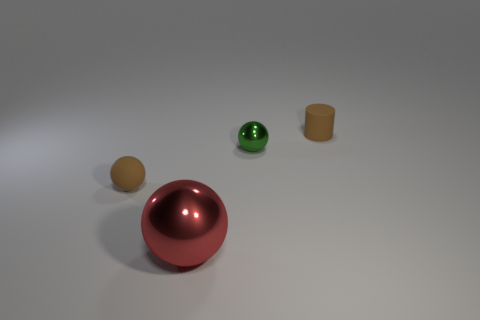Add 2 green balls. How many objects exist? 6 Subtract all spheres. How many objects are left? 1 Add 3 big green cylinders. How many big green cylinders exist? 3 Subtract 0 green cylinders. How many objects are left? 4 Subtract all tiny matte cubes. Subtract all small things. How many objects are left? 1 Add 3 big red balls. How many big red balls are left? 4 